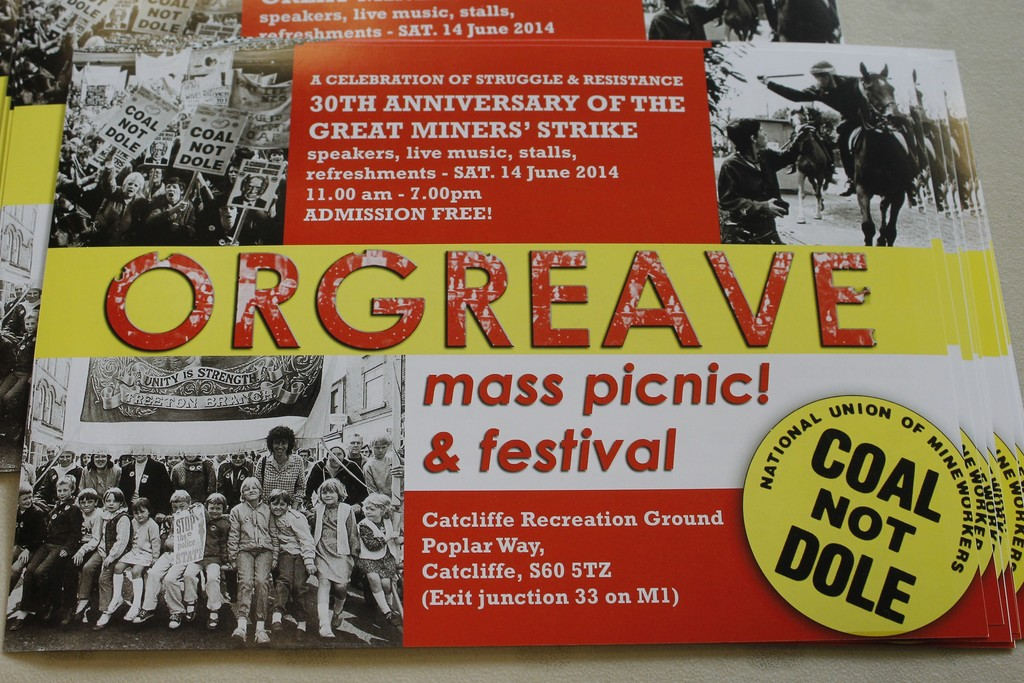What activities can attendees expect at the Orgreave festival? Attendees at the Orgreave mass picnic & festival can look forward to a range of activities designed to both entertain and educate. The festival will include live music performances, likely reflecting the themes of struggle and resistance. There will be speeches from notable figures in the labor movement, educational stalls providing insights into various aspects of the miners' strike and its legacy, and a communal picnic space where people can gather to share stories and solidarity. Is there something special planned for this year's anniversary? While the specific details aren't mentioned on the poster, given the significant 30th anniversary, one can expect special commemorative activities such as the unveiling of a memorial, special tributes to key figures from the strike, and possibly a historical exhibition showcasing artifacts and photos from the time of the miners' strike. Such elements would provide a deeper connection to the history and impact of the event. 